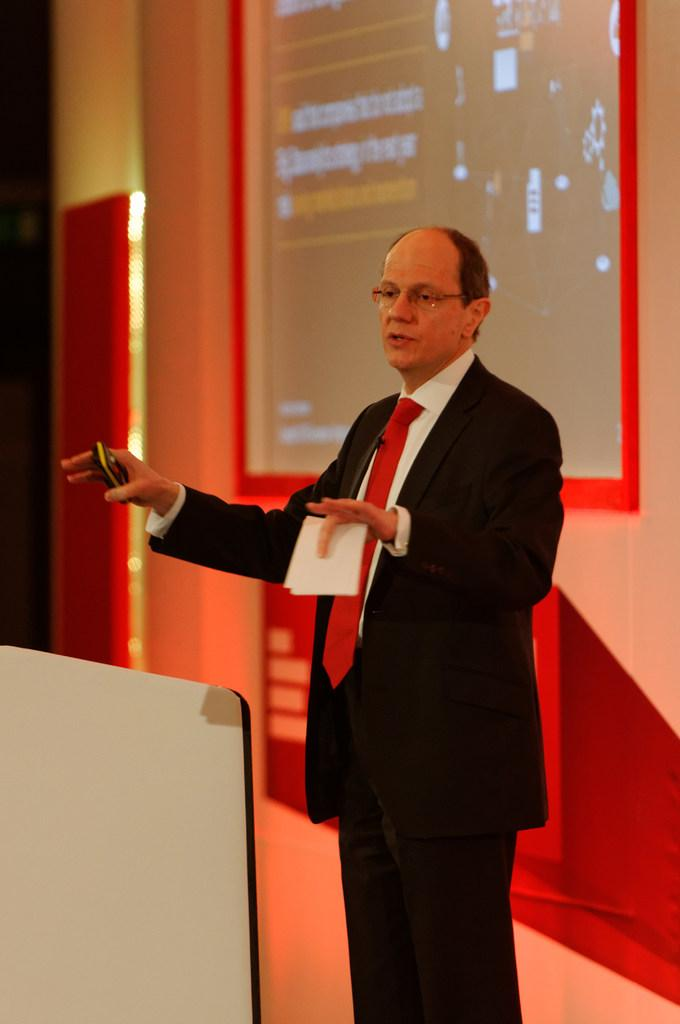What is the appearance of the man in the image? There is a bald-headed man in the image. What is the man wearing? The man is wearing a black shirt. What is the man holding in the image? The man is holding a paper. What can be seen on the wall behind the man? There is a screen on the wall behind the man. What type of crook is the man using to climb the church in the image? There is no crook or church present in the image. The man is holding a paper and standing in front of a screen. 